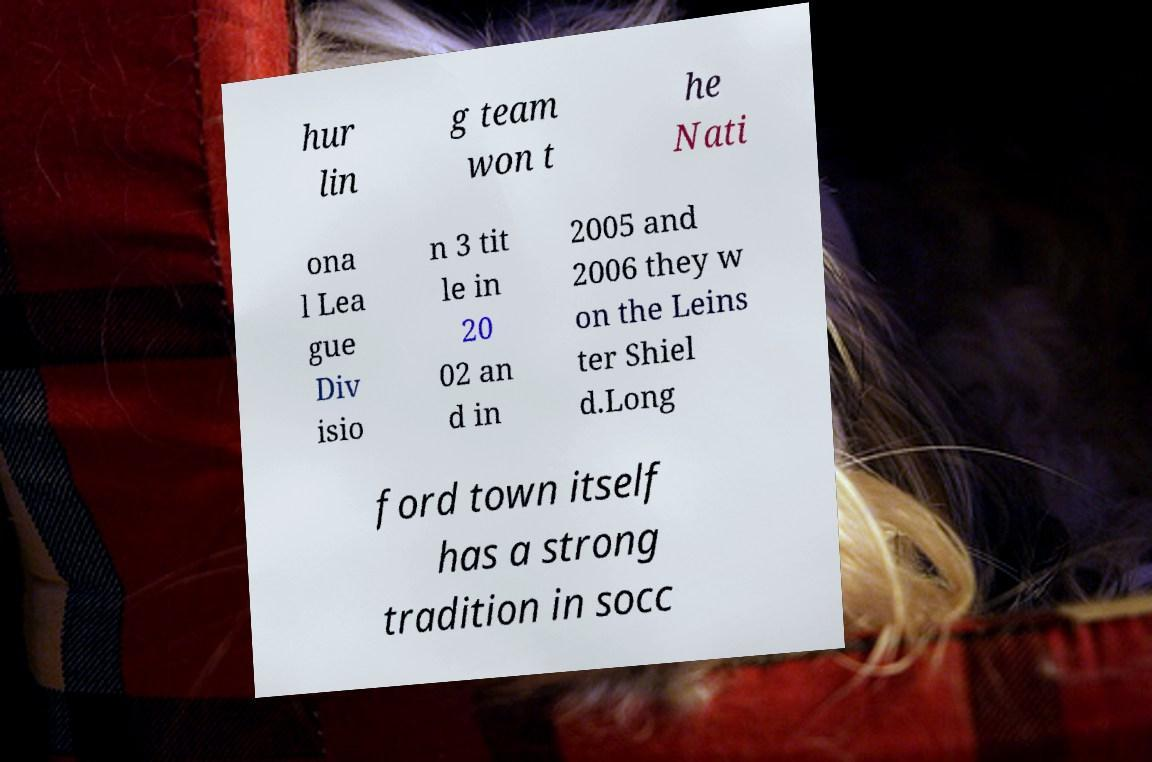Please identify and transcribe the text found in this image. hur lin g team won t he Nati ona l Lea gue Div isio n 3 tit le in 20 02 an d in 2005 and 2006 they w on the Leins ter Shiel d.Long ford town itself has a strong tradition in socc 